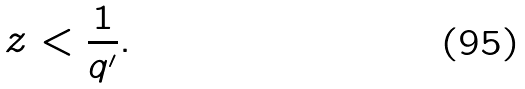<formula> <loc_0><loc_0><loc_500><loc_500>z < \frac { 1 } { q ^ { \prime } } .</formula> 